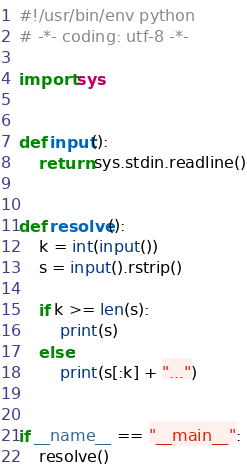<code> <loc_0><loc_0><loc_500><loc_500><_Python_>#!/usr/bin/env python
# -*- coding: utf-8 -*-

import sys


def input():
    return sys.stdin.readline()


def resolve():
    k = int(input())
    s = input().rstrip()

    if k >= len(s):
        print(s)
    else:
        print(s[:k] + "...")


if __name__ == "__main__":
    resolve()

</code> 